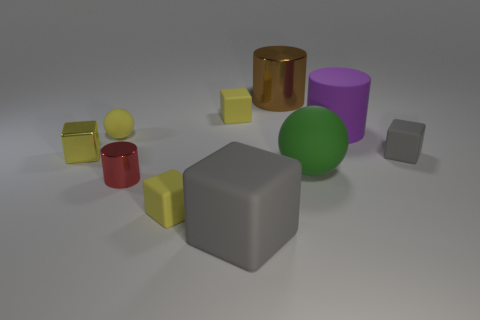What number of spheres are behind the big green object and in front of the metal cube?
Make the answer very short. 0. How many things are either small shiny things in front of the green matte thing or tiny gray rubber cubes right of the red object?
Offer a terse response. 2. What number of other objects are there of the same shape as the small gray object?
Offer a terse response. 4. There is a big object to the left of the big brown cylinder; does it have the same color as the tiny ball?
Your answer should be very brief. No. How many other objects are the same size as the green object?
Give a very brief answer. 3. Is the material of the tiny red cylinder the same as the large purple cylinder?
Your response must be concise. No. There is a big matte ball that is right of the metallic object behind the purple matte cylinder; what color is it?
Your answer should be compact. Green. There is another rubber object that is the same shape as the large green matte object; what size is it?
Offer a terse response. Small. Does the big rubber block have the same color as the matte cylinder?
Offer a very short reply. No. What number of brown metal things are left of the small object that is right of the purple rubber thing that is right of the brown thing?
Your response must be concise. 1. 